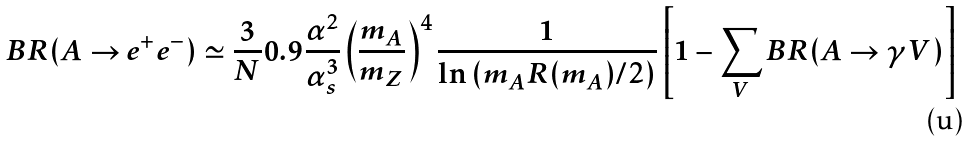<formula> <loc_0><loc_0><loc_500><loc_500>B R ( A \rightarrow e ^ { + } e ^ { - } ) \simeq \frac { 3 } { N } 0 . 9 \frac { \alpha ^ { 2 } } { \alpha _ { s } ^ { 3 } } \left ( \frac { m _ { A } } { m _ { Z } } \right ) ^ { 4 } \frac { 1 } { \ln \left ( m _ { A } R ( m _ { A } ) / 2 \right ) } \left [ 1 - \sum _ { V } B R ( A \rightarrow \gamma V ) \right ]</formula> 